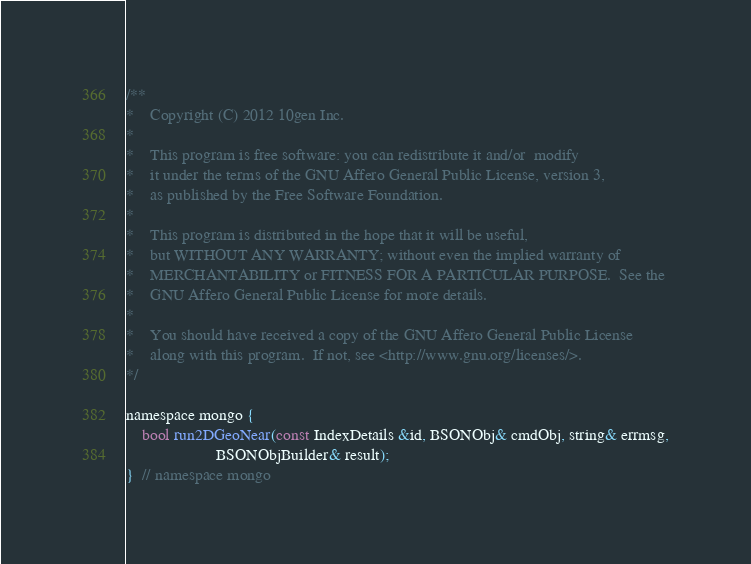<code> <loc_0><loc_0><loc_500><loc_500><_C_>/**
*    Copyright (C) 2012 10gen Inc.
*
*    This program is free software: you can redistribute it and/or  modify
*    it under the terms of the GNU Affero General Public License, version 3,
*    as published by the Free Software Foundation.
*
*    This program is distributed in the hope that it will be useful,
*    but WITHOUT ANY WARRANTY; without even the implied warranty of
*    MERCHANTABILITY or FITNESS FOR A PARTICULAR PURPOSE.  See the
*    GNU Affero General Public License for more details.
*
*    You should have received a copy of the GNU Affero General Public License
*    along with this program.  If not, see <http://www.gnu.org/licenses/>.
*/

namespace mongo {
    bool run2DGeoNear(const IndexDetails &id, BSONObj& cmdObj, string& errmsg,
                      BSONObjBuilder& result);
}  // namespace mongo
</code> 